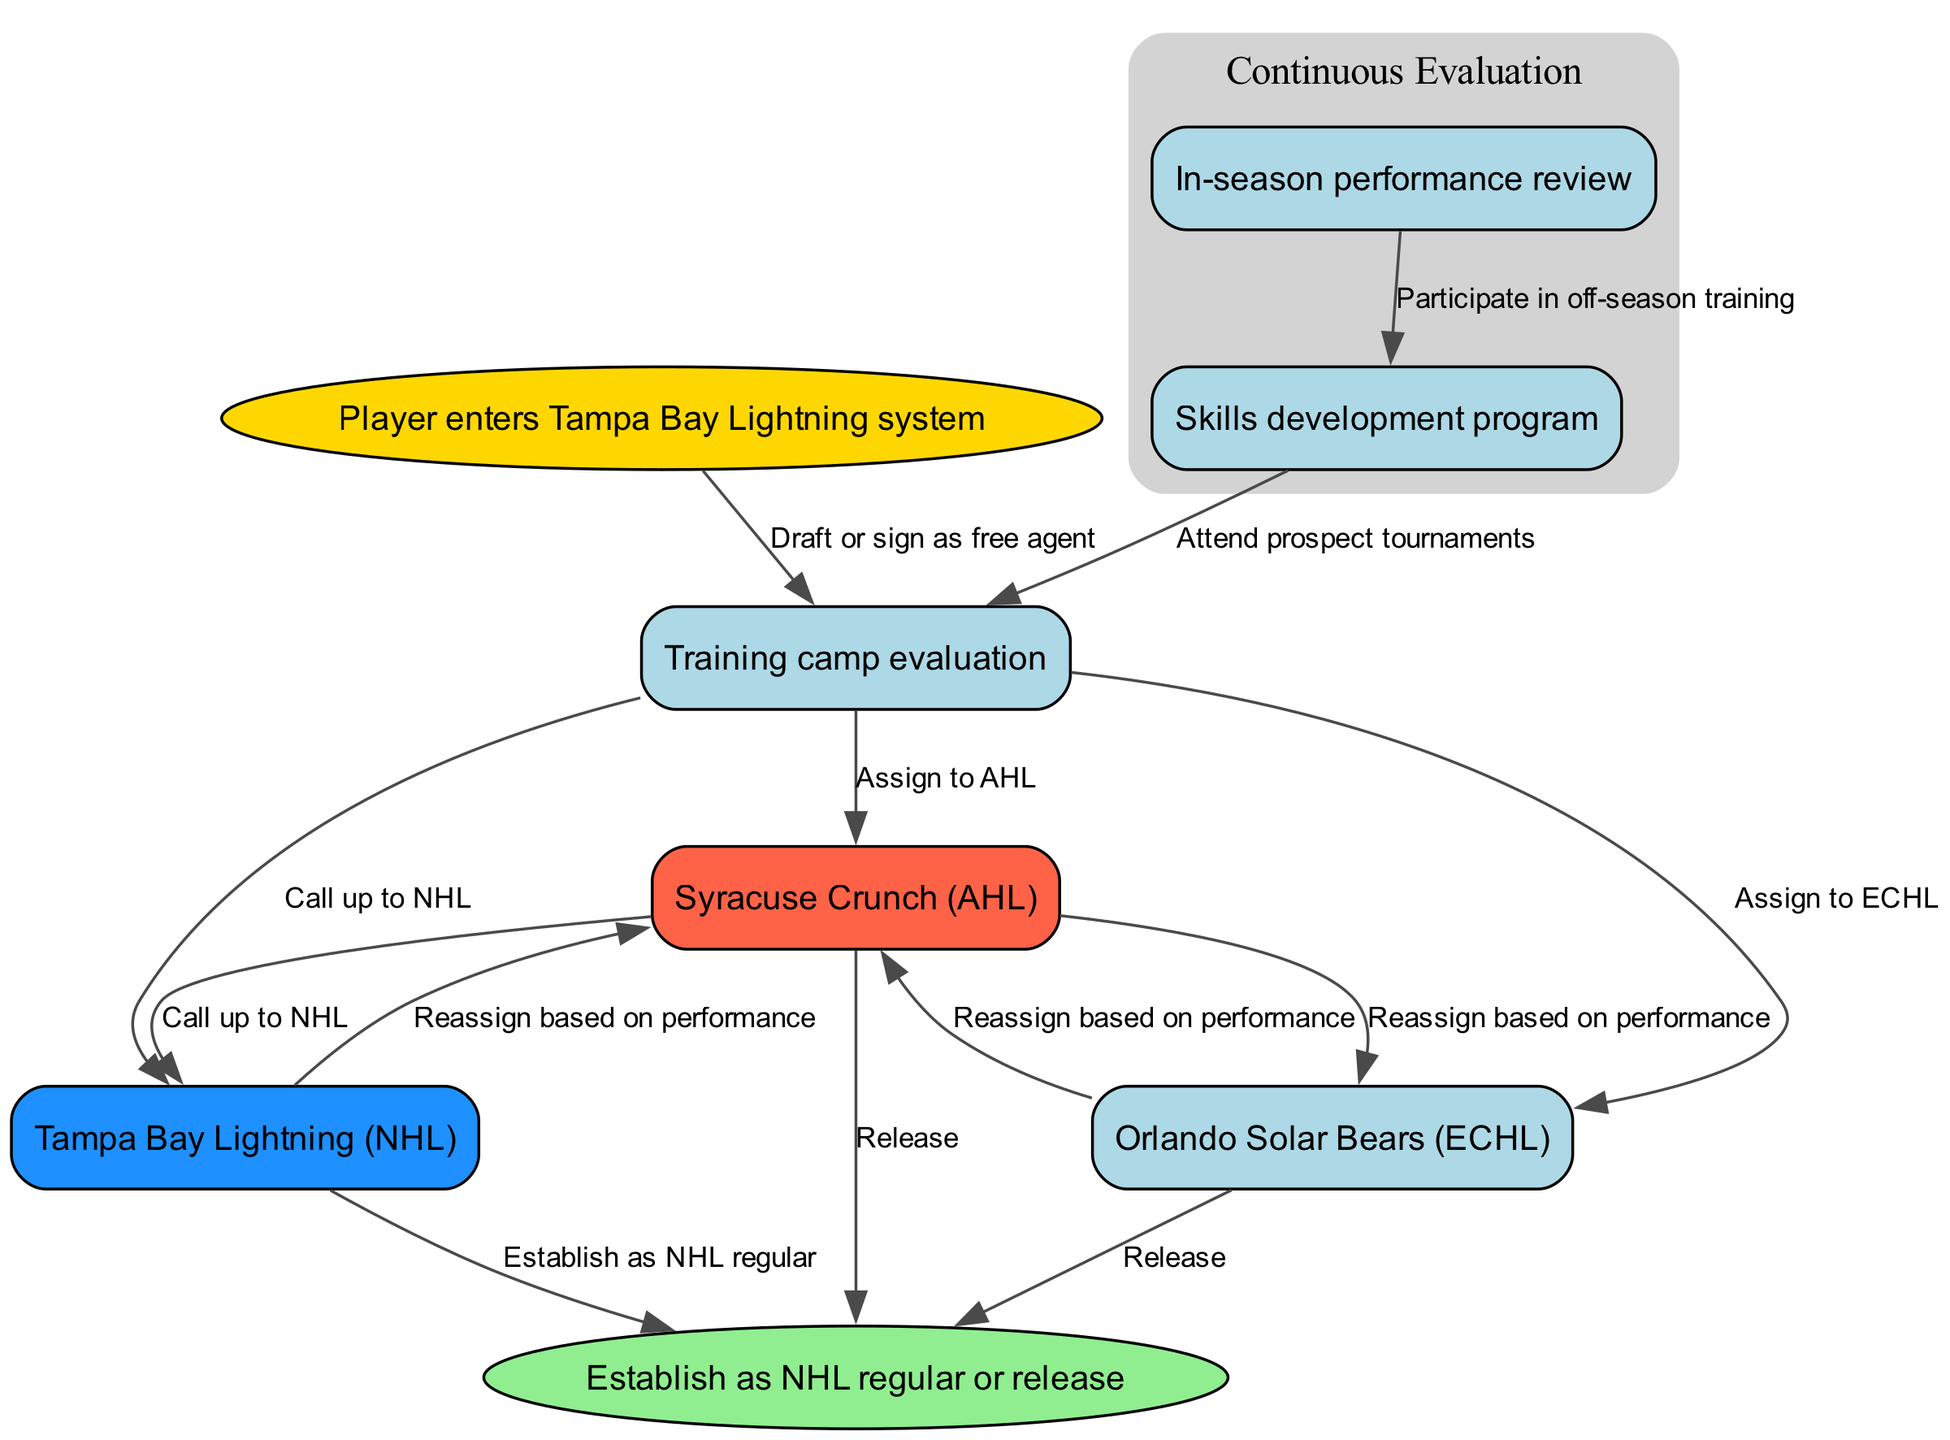What is the starting point of the diagram? The starting point is indicated as "Player enters Tampa Bay Lightning system," which leads into the evaluation process.
Answer: Player enters Tampa Bay Lightning system How many nodes are present in the diagram? Counting all unique boxes in the diagram, there are a total of 7 nodes including the start and end points.
Answer: 7 What color represents the Syracuse Crunch in the diagram? The Syracuse Crunch is highlighted in red, specifically the color #FF6347.
Answer: Red What happens after "Training camp evaluation" if a player performs well? A player who performs well can be assigned to the Syracuse Crunch or called up to the Tampa Bay Lightning, as shown by the outgoing edges from that node.
Answer: Assigned to Syracuse Crunch or called up to NHL Which node leads to the "Skills development program"? The node "In-season performance review" directly leads to the "Skills development program," indicating that performance reviews contribute to skill development.
Answer: In-season performance review If a player is assigned to the Orlando Solar Bears, what can happen next based on their performance? If assigned to the Orlando Solar Bears, a player can be reassigned to the Syracuse Crunch or released depending on their performance as indicated in the outgoing edges.
Answer: Reassigned to Syracuse Crunch or released What is the end goal for a player who successfully integrates into the NHL? The end goal for a successfully performing player is to "Establish as NHL regular," which indicates they've secured their position in the NHL team.
Answer: Establish as NHL regular What process follows participation in the "Skills development program"? After participating in the Skills development program, a player attends prospect tournaments, which aims to further evaluate their skills.
Answer: Attend prospect tournaments What type of evaluation occurs continuously throughout the player's development? The diagram indicates a "Continuous Evaluation" which encompasses both the in-season performance review and the skills development program as part of the overarching development strategy.
Answer: Continuous Evaluation 